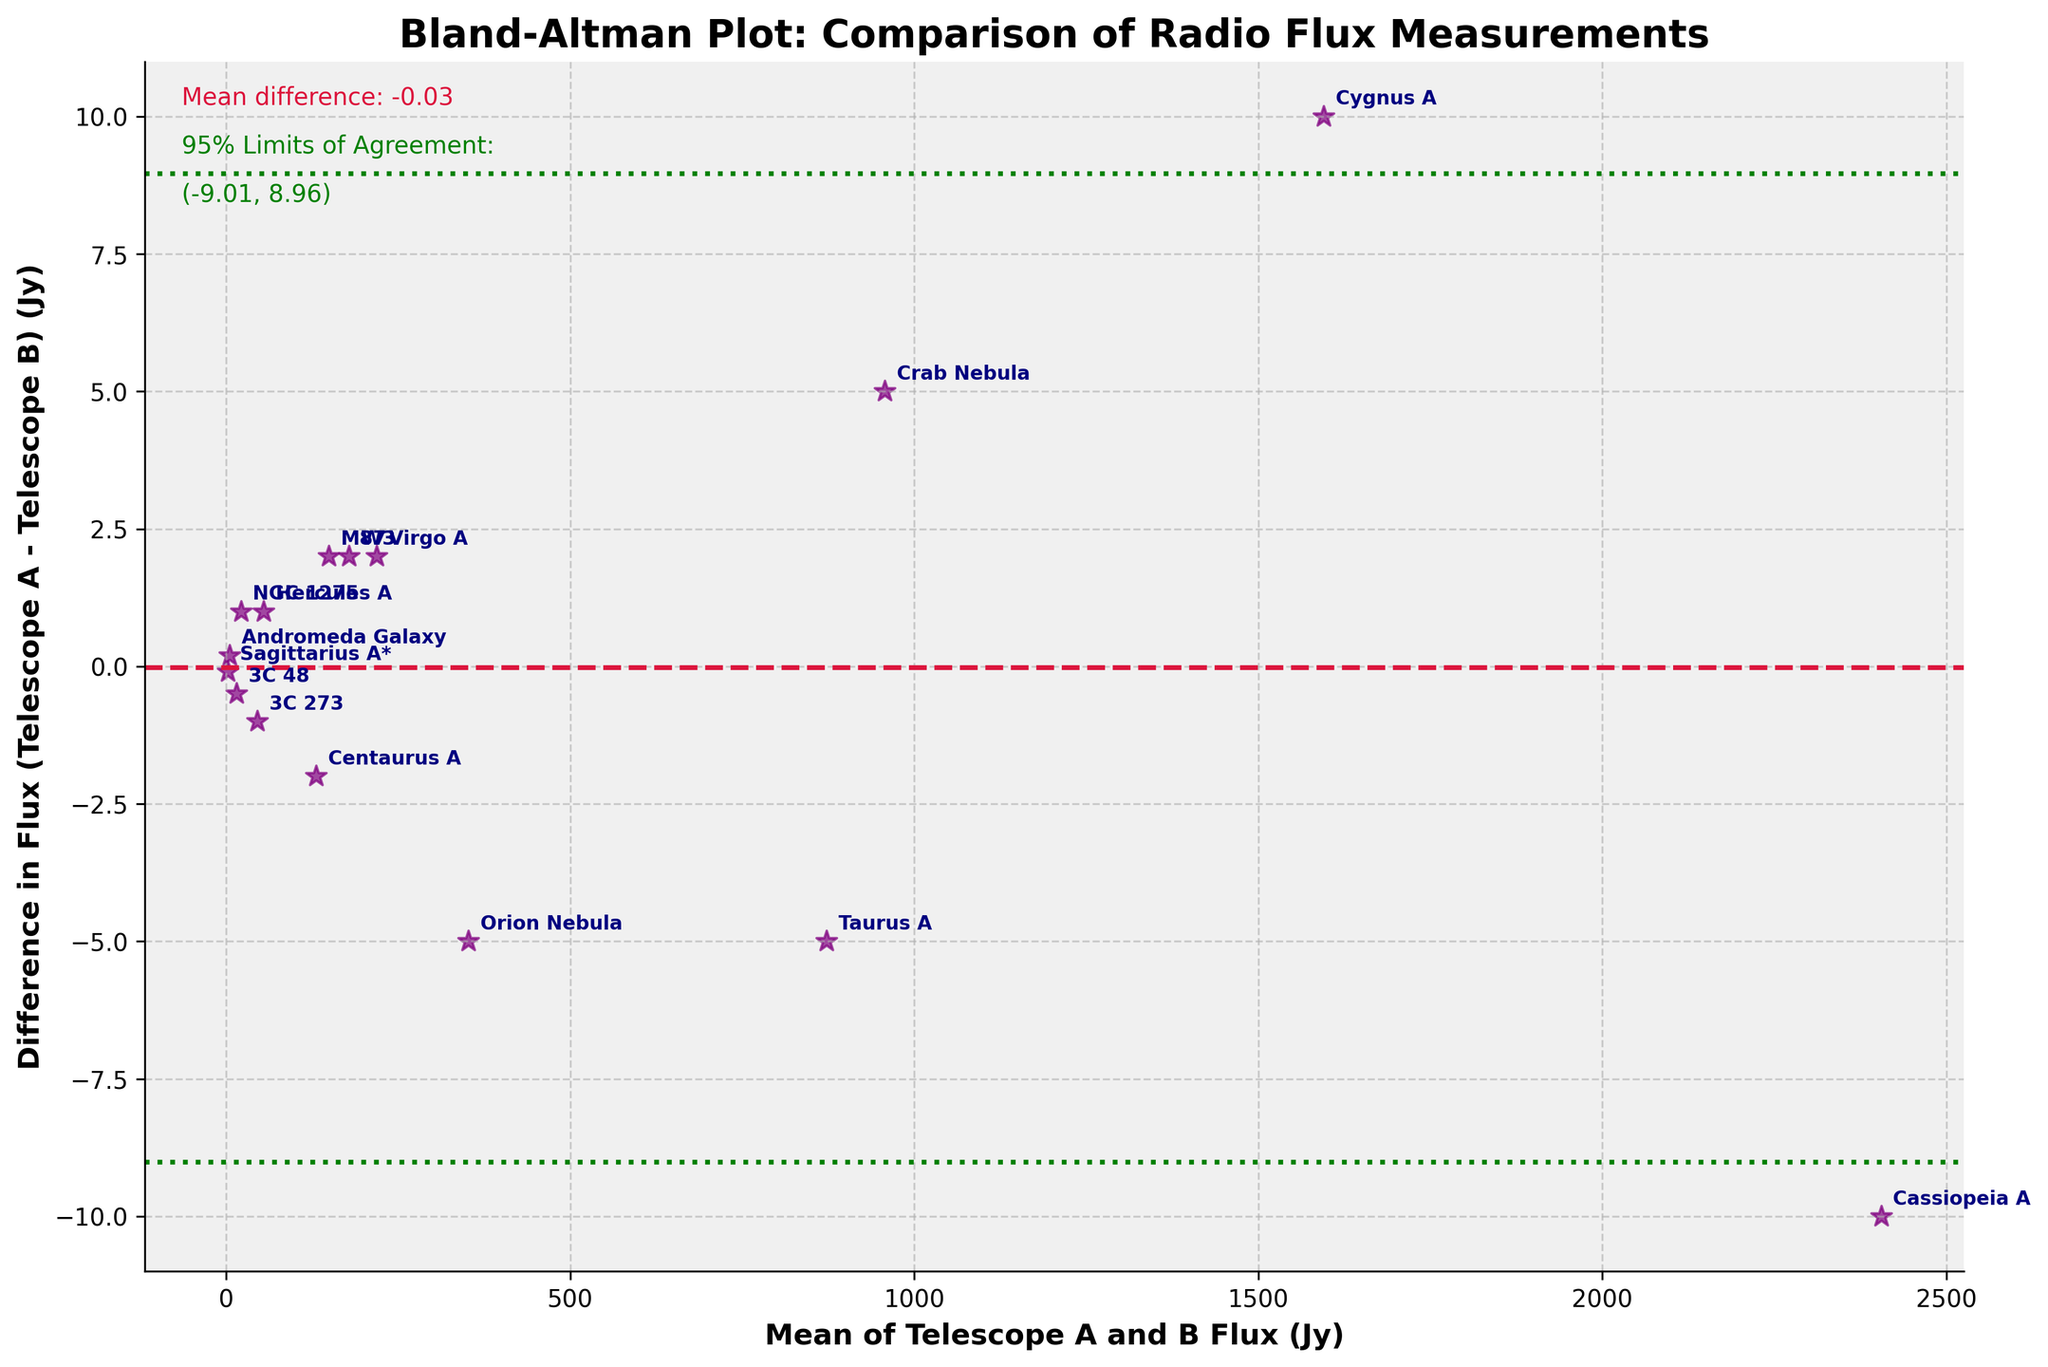What is the mean difference in flux between Telescope A and B? The mean difference can be determined by referring to the text annotation near the horizontal dashed line. The figure bases this mean difference on the average of the differences between the two telescopes' measurements.
Answer: -0.53 Jy How many celestial objects are compared in the figure? The number of celestial objects can be counted by the number of data points on the plot, each of which is labeled with the object's name.
Answer: 15 Which celestial object has the highest mean flux? To determine the celestial object with the highest mean flux, one can find the data point that is farthest to the right on the x-axis (Mean of Telescope A and B Flux).
Answer: Cassiopeia A Are there any celestial objects for which both telescopes measured identical flux? Identical measurements would appear along the horizontal line at y=0 on the difference axis. You need to find any points that fall exactly on this line.
Answer: Yes, 3C 48 What is the range for the 95% limits of agreement? The 95% limits of agreement are indicated by the two horizontal green dashed lines. The values associated with these limits are given in the text annotation on the plot.
Answer: (-4.15 Jy, 3.09 Jy) Which celestial object has the largest variation between the measurements from the two telescopes? The largest variation corresponds to the point that has the greatest distance from y=0 (the horizontal axis), which can be identified by looking for the point farthest away vertically from the center line.
Answer: Centaurus A What is the flux difference for the Crab Nebula? Locate the data point labeled "Crab Nebula" and determine its vertical position relative to the horizontal axis labeled "Difference in Flux".
Answer: 5 Jy What is the difference in flux for 3C 273 between the two telescopes? Find the data point labeled "3C 273". Its vertical position indicates the difference in flux on the y-axis.
Answer: -1 Jy Which celestial object has a mean flux closest to 200 Jy? Look for the data point positioned closest to 200 Jy on the x-axis labeled "Mean of Telescope A and B Flux".
Answer: Orion Nebula Is there any trend or systematic bias visible in the flux measurements between the two telescopes? Examine the distribution of points around the zero difference line and the shape of the scatter. If the points are randomly scattered without a pattern, there is no systematic bias.
Answer: No systematic bias 